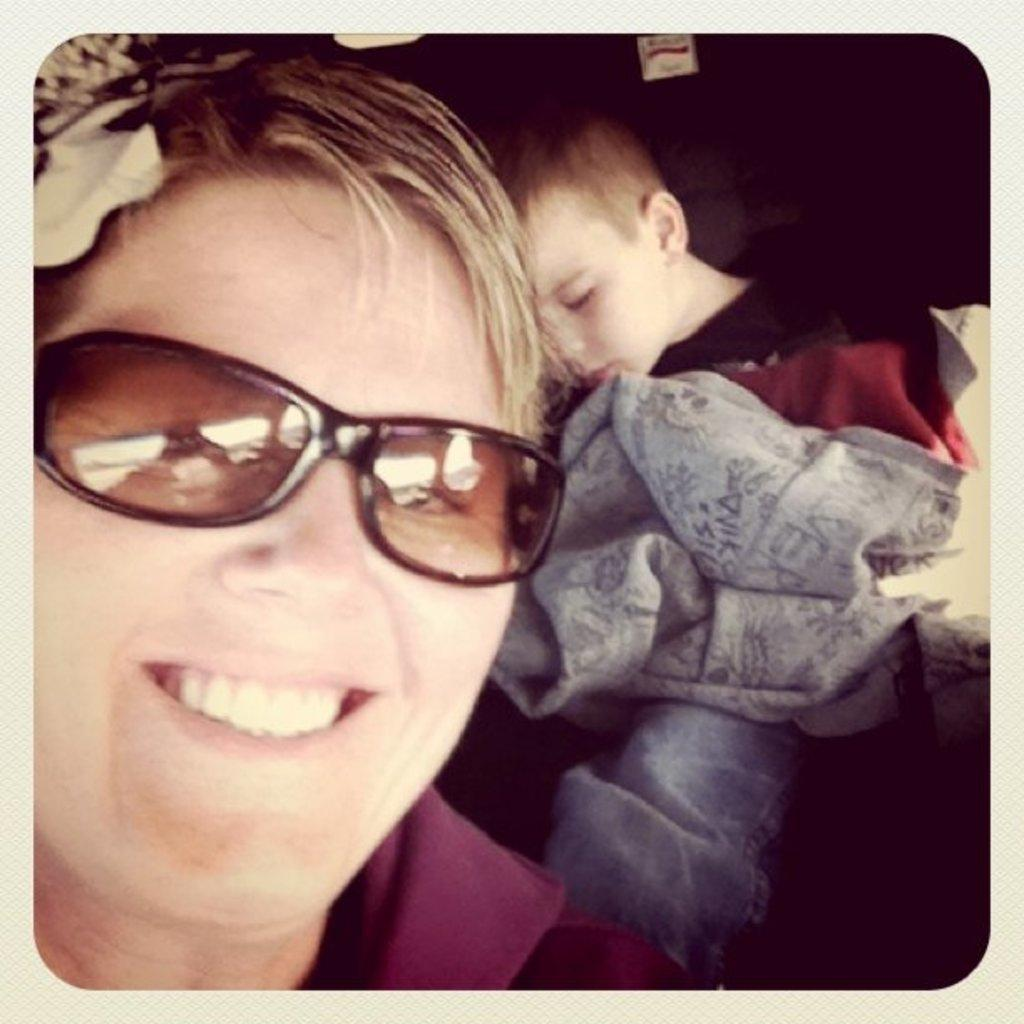What is the person in the image wearing on their face? The person in the image is wearing glasses. Who else is present in the image besides the person with glasses? There is a kid in the image. What type of object can be seen in the image that is made of fabric? There is a cloth visible in the image. What type of fang can be seen in the image? There are no fangs present in the image. 